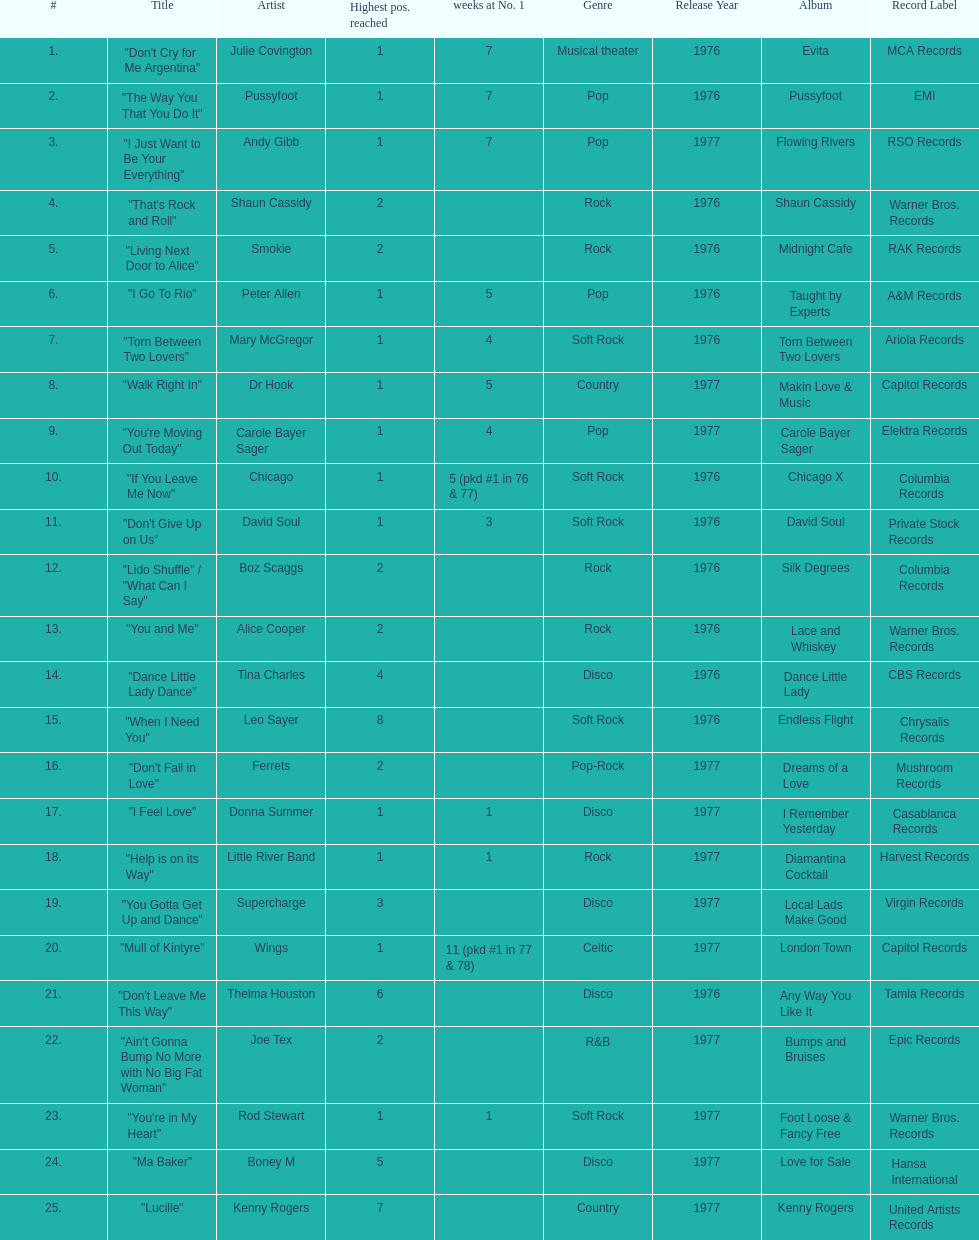How many songs in the table only reached position number 2? 6. Parse the full table. {'header': ['#', 'Title', 'Artist', 'Highest pos. reached', 'weeks at No. 1', 'Genre', 'Release Year', 'Album', 'Record Label'], 'rows': [['1.', '"Don\'t Cry for Me Argentina"', 'Julie Covington', '1', '7', 'Musical theater', '1976', 'Evita', 'MCA Records'], ['2.', '"The Way You That You Do It"', 'Pussyfoot', '1', '7', 'Pop', '1976', 'Pussyfoot', 'EMI'], ['3.', '"I Just Want to Be Your Everything"', 'Andy Gibb', '1', '7', 'Pop', '1977', 'Flowing Rivers', 'RSO Records'], ['4.', '"That\'s Rock and Roll"', 'Shaun Cassidy', '2', '', 'Rock', '1976', 'Shaun Cassidy', 'Warner Bros. Records'], ['5.', '"Living Next Door to Alice"', 'Smokie', '2', '', 'Rock', '1976', 'Midnight Cafe', 'RAK Records'], ['6.', '"I Go To Rio"', 'Peter Allen', '1', '5', 'Pop', '1976', 'Taught by Experts', 'A&M Records'], ['7.', '"Torn Between Two Lovers"', 'Mary McGregor', '1', '4', 'Soft Rock', '1976', 'Torn Between Two Lovers', 'Ariola Records'], ['8.', '"Walk Right In"', 'Dr Hook', '1', '5', 'Country', '1977', 'Makin Love & Music', 'Capitol Records'], ['9.', '"You\'re Moving Out Today"', 'Carole Bayer Sager', '1', '4', 'Pop', '1977', 'Carole Bayer Sager', 'Elektra Records'], ['10.', '"If You Leave Me Now"', 'Chicago', '1', '5 (pkd #1 in 76 & 77)', 'Soft Rock', '1976', 'Chicago X', 'Columbia Records'], ['11.', '"Don\'t Give Up on Us"', 'David Soul', '1', '3', 'Soft Rock', '1976', 'David Soul', 'Private Stock Records'], ['12.', '"Lido Shuffle" / "What Can I Say"', 'Boz Scaggs', '2', '', 'Rock', '1976', 'Silk Degrees', 'Columbia Records'], ['13.', '"You and Me"', 'Alice Cooper', '2', '', 'Rock', '1976', 'Lace and Whiskey', 'Warner Bros. Records'], ['14.', '"Dance Little Lady Dance"', 'Tina Charles', '4', '', 'Disco', '1976', 'Dance Little Lady', 'CBS Records'], ['15.', '"When I Need You"', 'Leo Sayer', '8', '', 'Soft Rock', '1976', 'Endless Flight', 'Chrysalis Records'], ['16.', '"Don\'t Fall in Love"', 'Ferrets', '2', '', 'Pop-Rock', '1977', 'Dreams of a Love', 'Mushroom Records'], ['17.', '"I Feel Love"', 'Donna Summer', '1', '1', 'Disco', '1977', 'I Remember Yesterday', 'Casablanca Records'], ['18.', '"Help is on its Way"', 'Little River Band', '1', '1', 'Rock', '1977', 'Diamantina Cocktail', 'Harvest Records'], ['19.', '"You Gotta Get Up and Dance"', 'Supercharge', '3', '', 'Disco', '1977', 'Local Lads Make Good', 'Virgin Records'], ['20.', '"Mull of Kintyre"', 'Wings', '1', '11 (pkd #1 in 77 & 78)', 'Celtic', '1977', 'London Town', 'Capitol Records'], ['21.', '"Don\'t Leave Me This Way"', 'Thelma Houston', '6', '', 'Disco', '1976', 'Any Way You Like It', 'Tamla Records'], ['22.', '"Ain\'t Gonna Bump No More with No Big Fat Woman"', 'Joe Tex', '2', '', 'R&B', '1977', 'Bumps and Bruises', 'Epic Records'], ['23.', '"You\'re in My Heart"', 'Rod Stewart', '1', '1', 'Soft Rock', '1977', 'Foot Loose & Fancy Free', 'Warner Bros. Records'], ['24.', '"Ma Baker"', 'Boney M', '5', '', 'Disco', '1977', 'Love for Sale', 'Hansa International'], ['25.', '"Lucille"', 'Kenny Rogers', '7', '', 'Country', '1977', 'Kenny Rogers', 'United Artists Records']]} 